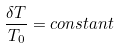Convert formula to latex. <formula><loc_0><loc_0><loc_500><loc_500>\frac { \delta T } { T _ { 0 } } = c o n s t a n t</formula> 